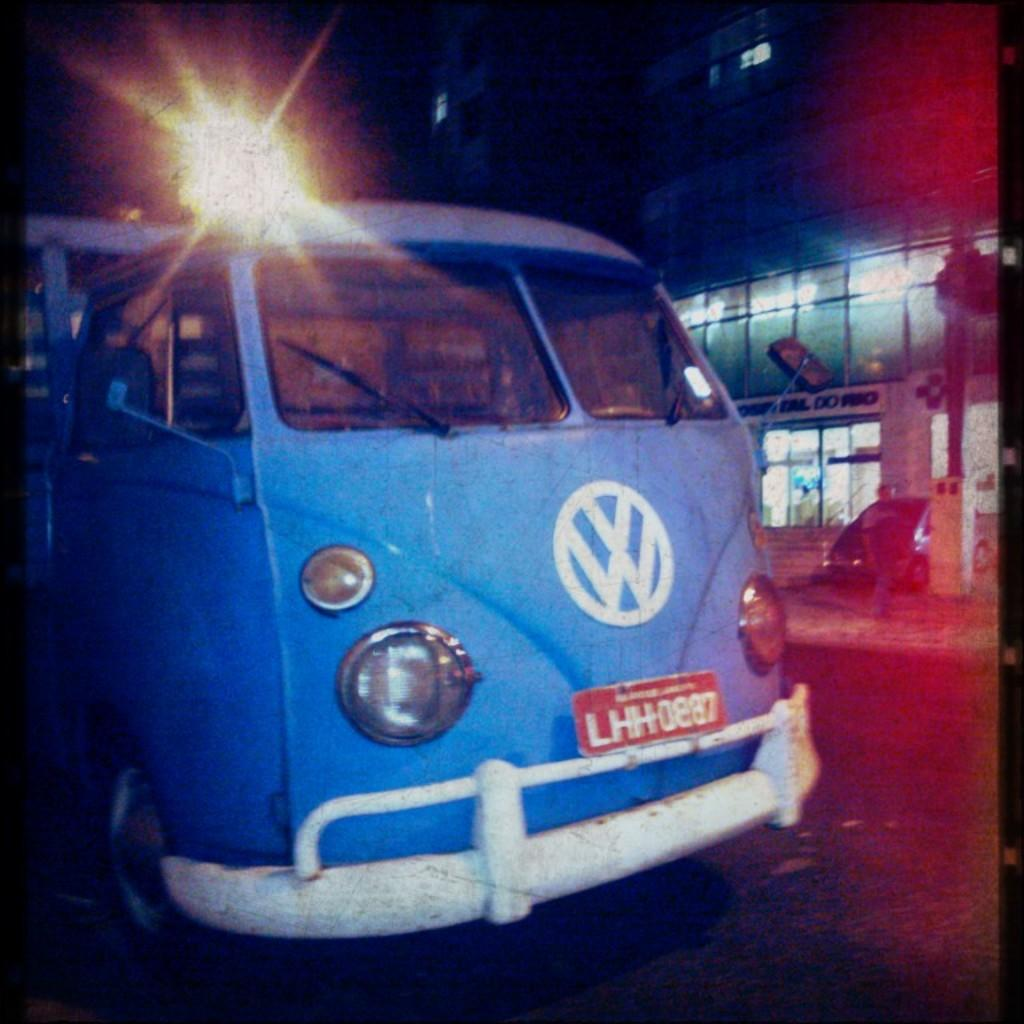What is happening in the foreground of the image? There is a vehicle moving on the road in the foreground of the image. What can be seen in the background of the image? In the background of the image, there is a person, another vehicle, a pole, a building, and a light. How many vehicles are visible in the image? There are two vehicles visible in the image, one in the foreground and one in the background. What type of structure is present in the background of the image? There is a building in the background of the image. How much money is being baked in the oven in the image? There is no oven present in the image, and therefore no money is being baked. 